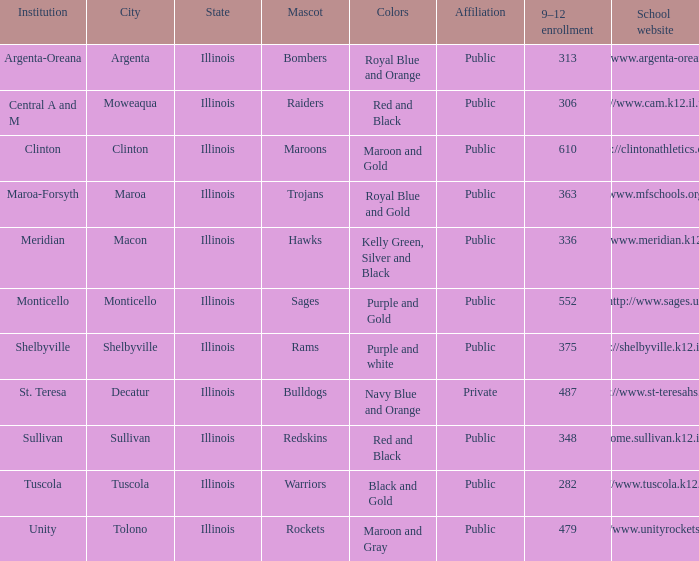What colors can you see players from Tolono, Illinois wearing? Maroon and Gray. 